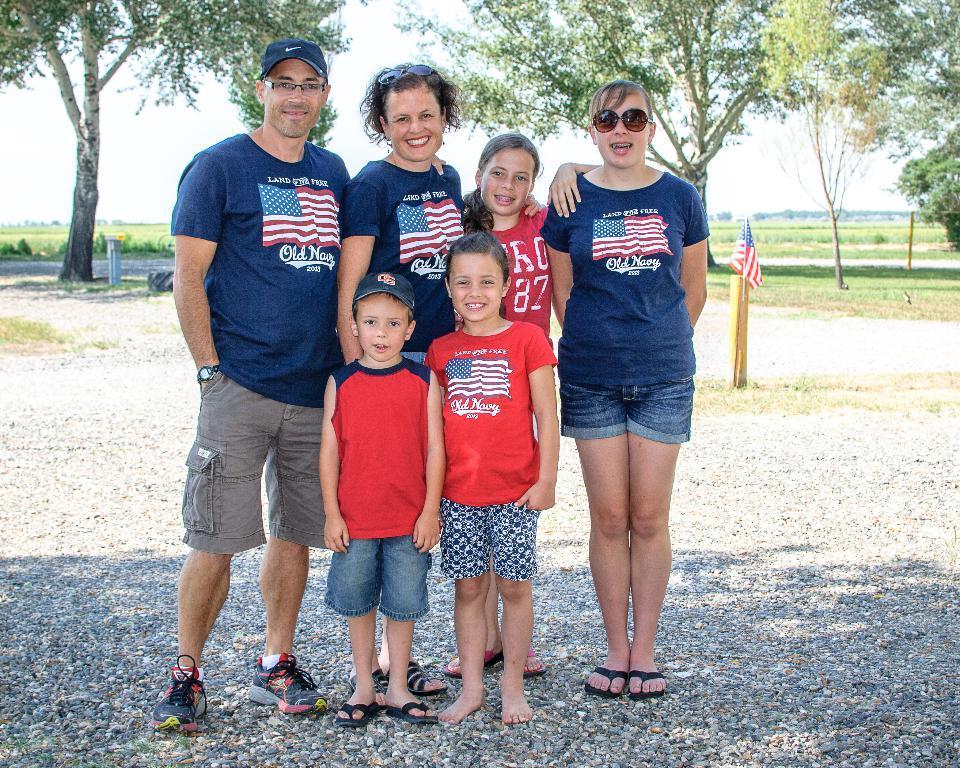Please provide a concise description of this image. In this image we can see a group of people standing on the ground. We can also see some stones, the flag, a wooden pole, a tire, some trees, grass and the sky which looks cloudy. 